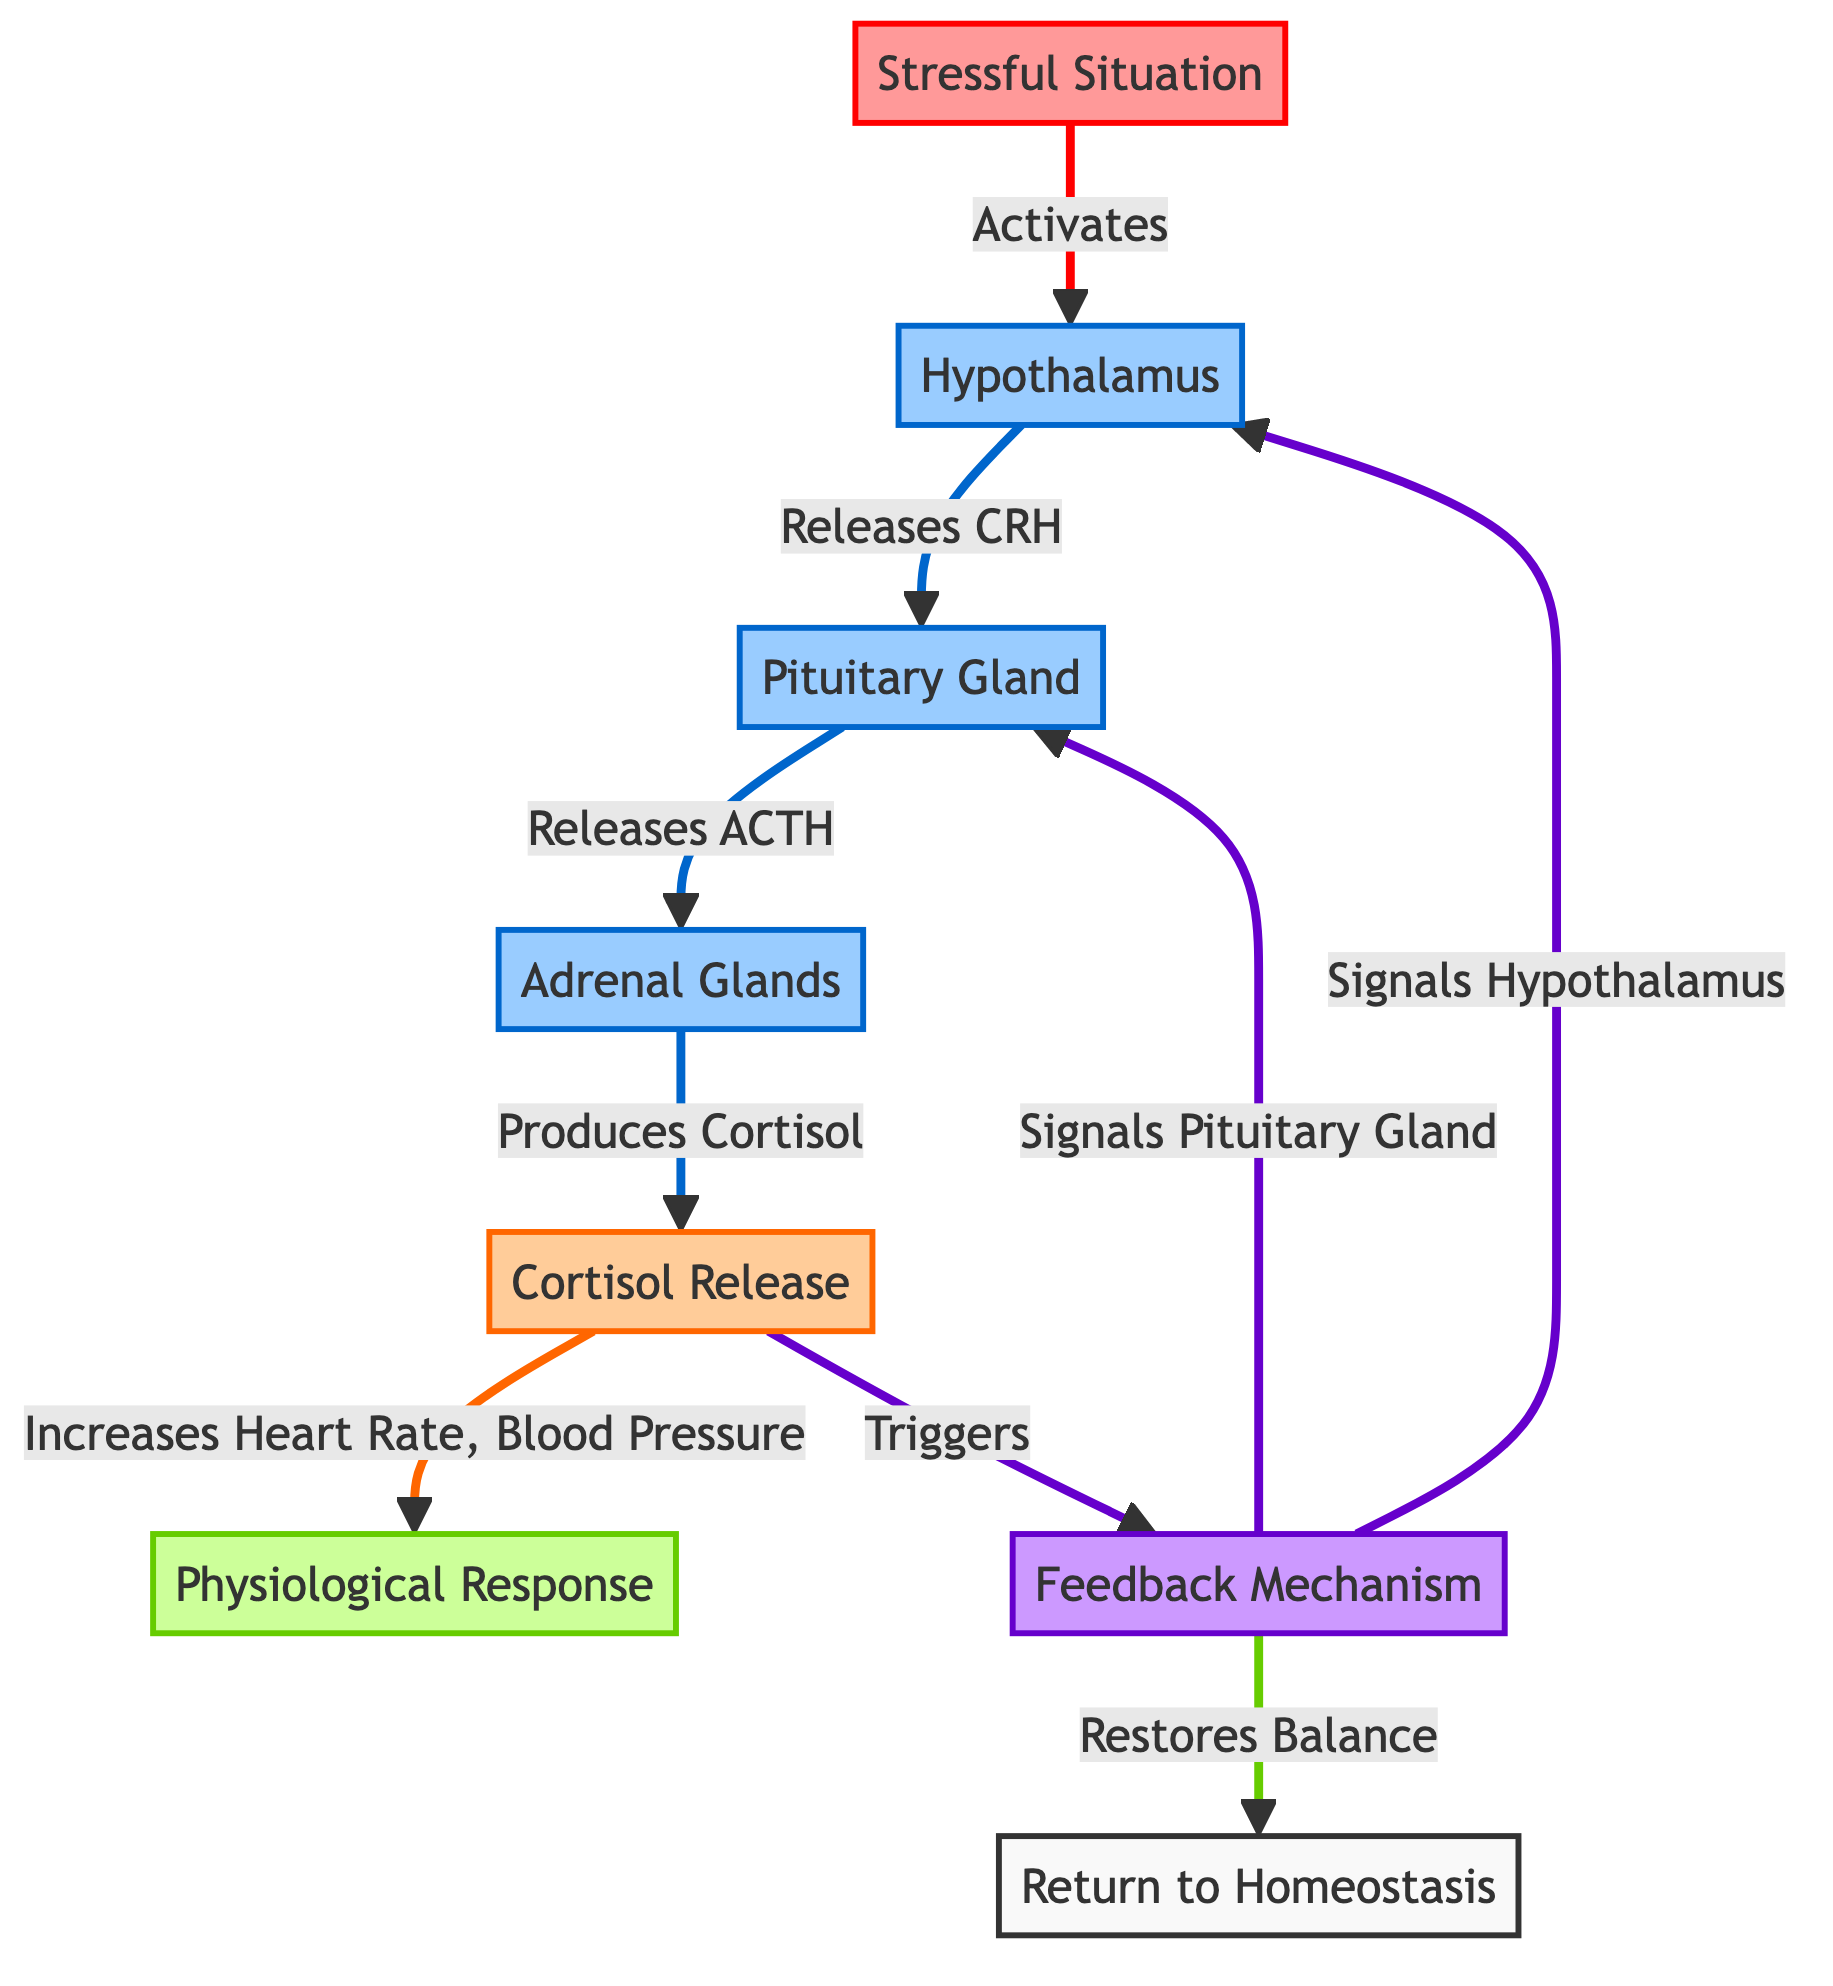What triggers the hypothalamus in the diagram? The diagram shows that a stressful situation activates the hypothalamus. This is indicated by the arrow from the "Stressful Situation" node pointing to the "Hypothalamus" node, labeled "Activates."
Answer: Stressful Situation What is produced by the adrenal glands? According to the diagram, the adrenal glands produce cortisol. This is shown by the arrow from the "Adrenal Glands" node pointing to the "Cortisol Release" node, labeled "Produces."
Answer: Cortisol How many glands are represented in the diagram? The diagram includes three gland nodes: the hypothalamus, pituitary gland, and adrenal glands. By counting these nodes, we find there are three in total.
Answer: 3 What is the final process in the stress response pathway? The diagram indicates that the final process in the stress response pathway is the return to homeostasis. This is shown by the last node connected back to the "Return to Homeostasis" labeled from the "Feedback Mechanism."
Answer: Return to Homeostasis Which hormone is released as part of the stress response? The diagram specifies that cortisol is the hormone released as part of the stress response. This is evident from the link between the "Adrenal Glands" node and the "Cortisol Release" node.
Answer: Cortisol What physiological changes are triggered by cortisol release? The diagram states that the release of cortisol leads to an increase in heart rate and blood pressure. This is detailed with the connections between the "Cortisol Release" node and the "Physiological Response" node.
Answer: Heart Rate, Blood Pressure What is the role of the feedback mechanism in the diagram? The feedback mechanism serves to signal back to the hypothalamus and pituitary gland, ultimately restoring balance according to the diagram. This is evidenced by the arrows from the "Feedback Mechanism" node leading to both glands with labels indicating signals and restoration.
Answer: Restore Balance 